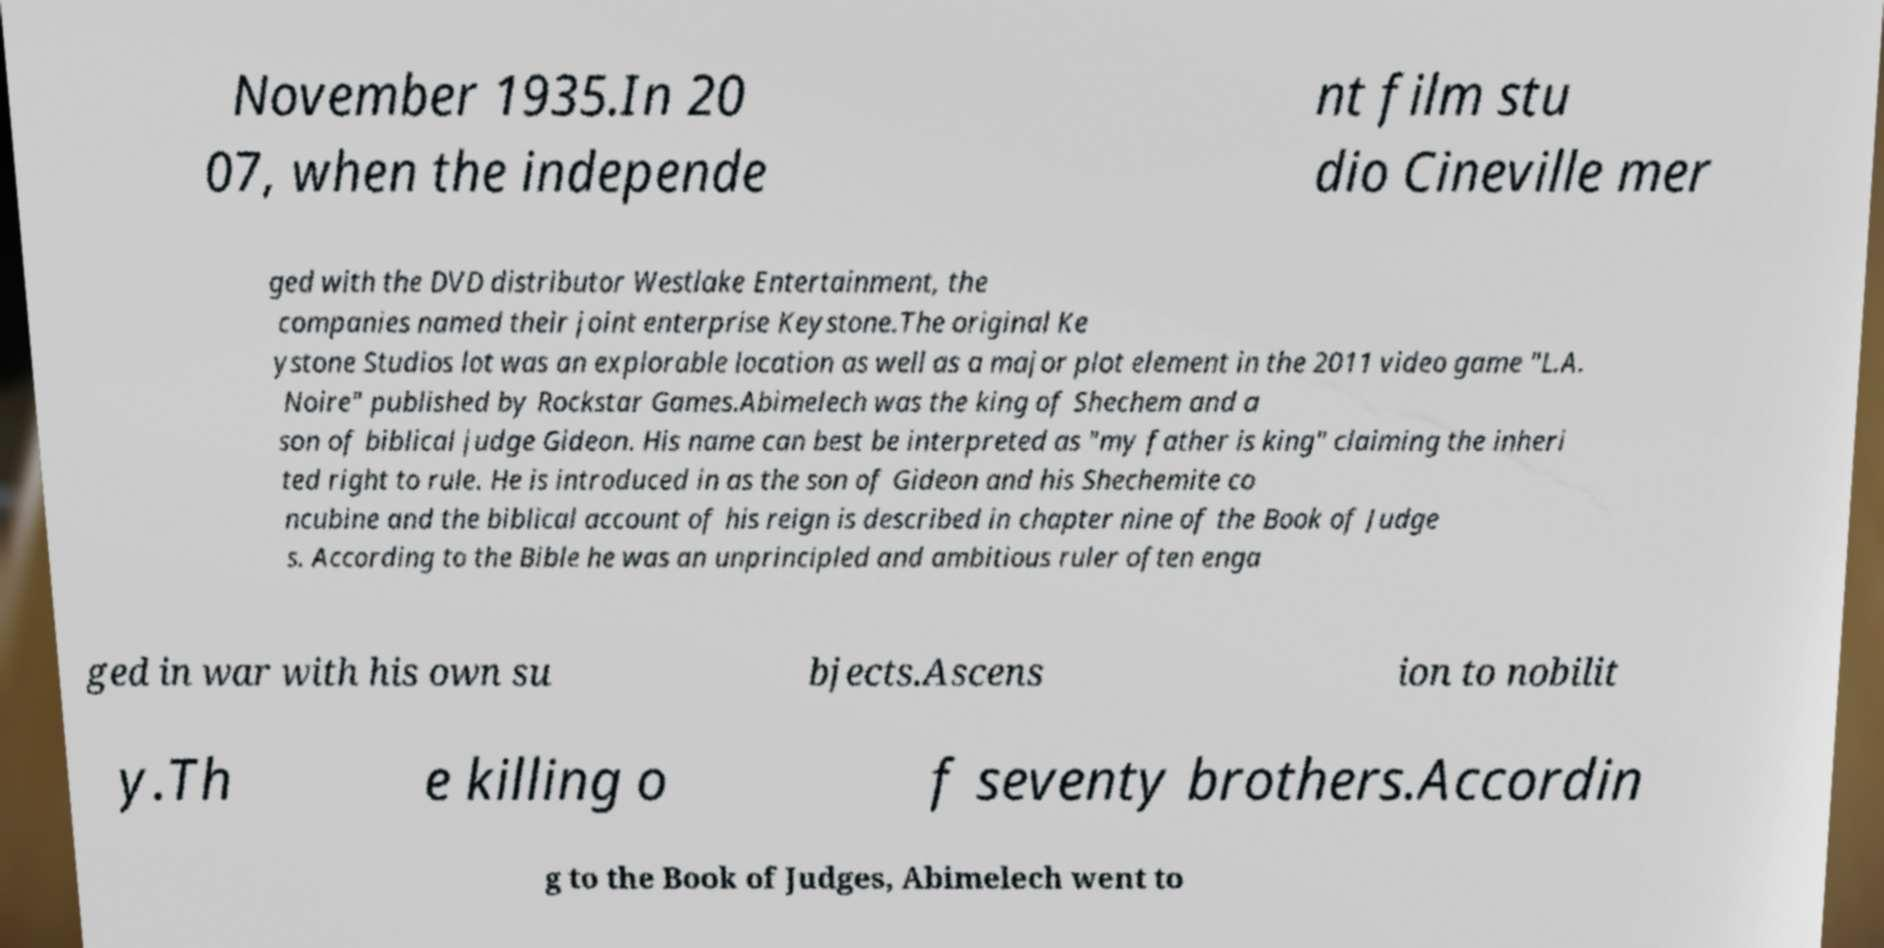Could you extract and type out the text from this image? November 1935.In 20 07, when the independe nt film stu dio Cineville mer ged with the DVD distributor Westlake Entertainment, the companies named their joint enterprise Keystone.The original Ke ystone Studios lot was an explorable location as well as a major plot element in the 2011 video game "L.A. Noire" published by Rockstar Games.Abimelech was the king of Shechem and a son of biblical judge Gideon. His name can best be interpreted as "my father is king" claiming the inheri ted right to rule. He is introduced in as the son of Gideon and his Shechemite co ncubine and the biblical account of his reign is described in chapter nine of the Book of Judge s. According to the Bible he was an unprincipled and ambitious ruler often enga ged in war with his own su bjects.Ascens ion to nobilit y.Th e killing o f seventy brothers.Accordin g to the Book of Judges, Abimelech went to 